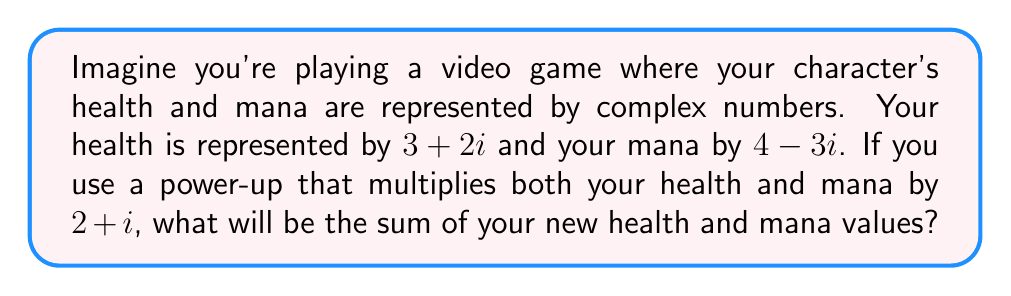Give your solution to this math problem. Let's approach this step-by-step:

1. First, we need to multiply the health by the power-up:
   $$(3 + 2i)(2 + i) = 6 + 3i + 4i + 2i^2$$
   Since $i^2 = -1$, this simplifies to:
   $$6 + 7i - 2 = 4 + 7i$$

2. Next, we multiply the mana by the power-up:
   $$(4 - 3i)(2 + i) = 8 + 4i - 6i - 3i^2$$
   Again, $i^2 = -1$, so this simplifies to:
   $$8 - 2i + 3 = 11 - 2i$$

3. Now we have the new health $(4 + 7i)$ and the new mana $(11 - 2i)$. To find their sum, we add the real and imaginary parts separately:
   $$(4 + 7i) + (11 - 2i) = (4 + 11) + (7i - 2i)$$
   $$= 15 + 5i$$

Therefore, the sum of the new health and mana values is $15 + 5i$.
Answer: $15 + 5i$ 